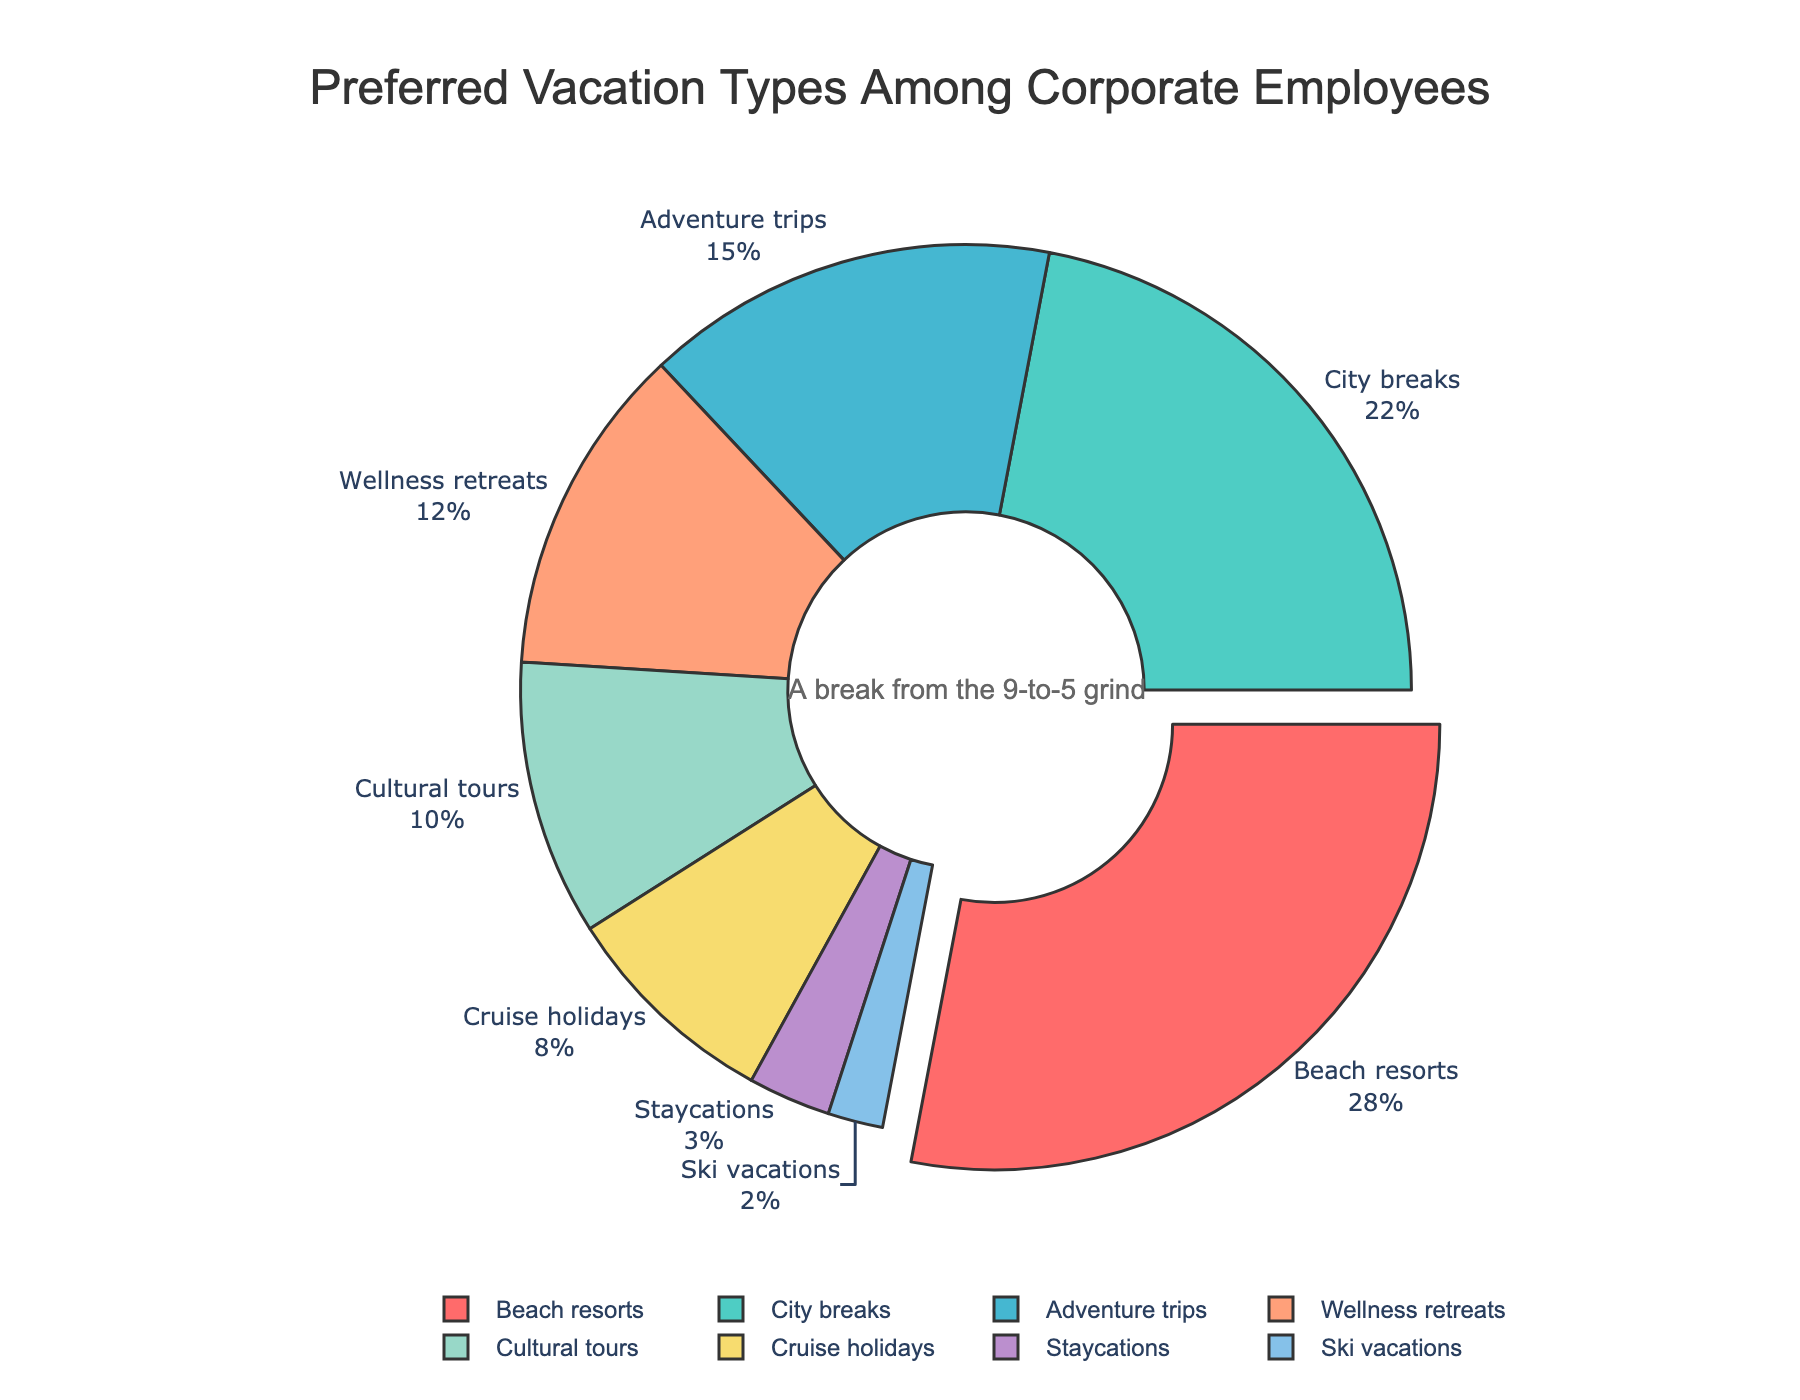Which vacation type is the most preferred among corporate employees? The vacation type occupying the largest segment of the pie chart, which is also labeled with the highest percentage, represents the most preferred vacation type.
Answer: Beach resorts Which vacation types constitute exactly 50% of the chart when combined? Add the percentages of different vacation types until the sum is 50%. Beach resorts (28%) and City breaks (22%) together make up 50%.
Answer: Beach resorts and City breaks What is the difference in percentage points between the most and least preferred vacation types? Subtract the percentage of the least preferred vacation type (Ski vacations, 2%) from the most preferred vacation type (Beach resorts, 28%). The difference is 28 - 2 = 26 percentage points.
Answer: 26 percentage points Which vacation type is represented by the blue color in the chart? Locate the blue color in the pie chart and check the associated label. The blue color is associated with City breaks.
Answer: City breaks Combine Adventure trips, Wellness retreats, and Cultural tours. What is their total percentage? Sum the percentages of Adventure trips (15%), Wellness retreats (12%), and Cultural tours (10%). The total is 15 + 12 + 10 = 37%.
Answer: 37% Which segment has a percentage closest to the average percentage of all vacation types? To find the average percentage, sum all percentages and divide by the number of vacation types. The sum is 28 + 22 + 15 + 12 + 10 + 8 + 3 + 2 = 100. The average is 100/8 = 12.5%. The closest percentage to this average is Wellness retreats at 12%.
Answer: Wellness retreats How does the percentage of Staycations compare to that of Cruise holidays? Compare the percentage of Staycations (3%) with that of Cruise holidays (8%). 3% is less than 8%.
Answer: Less than What is the second least preferred type of vacation? Identify the second smallest segment in the pie chart. Staycations (3%) is the second least preferred as Ski vacations (2%) is the least preferred.
Answer: Staycations Which vacation type occupies the segment just after the largest segment when the pie chart is rotated 90 degrees? The largest segment is Beach resorts. After a 90-degree rotation, the segment following Beach resorts is City breaks.
Answer: City breaks If Wellness retreats and Cultural tours combined are 22%, which other vacation type shares the same percentage? Compare the combined percentage of Wellness retreats (12%) and Cultural tours (10%), which equals 22%, with other vacation types. City breaks also have a percentage of 22%.
Answer: City breaks 